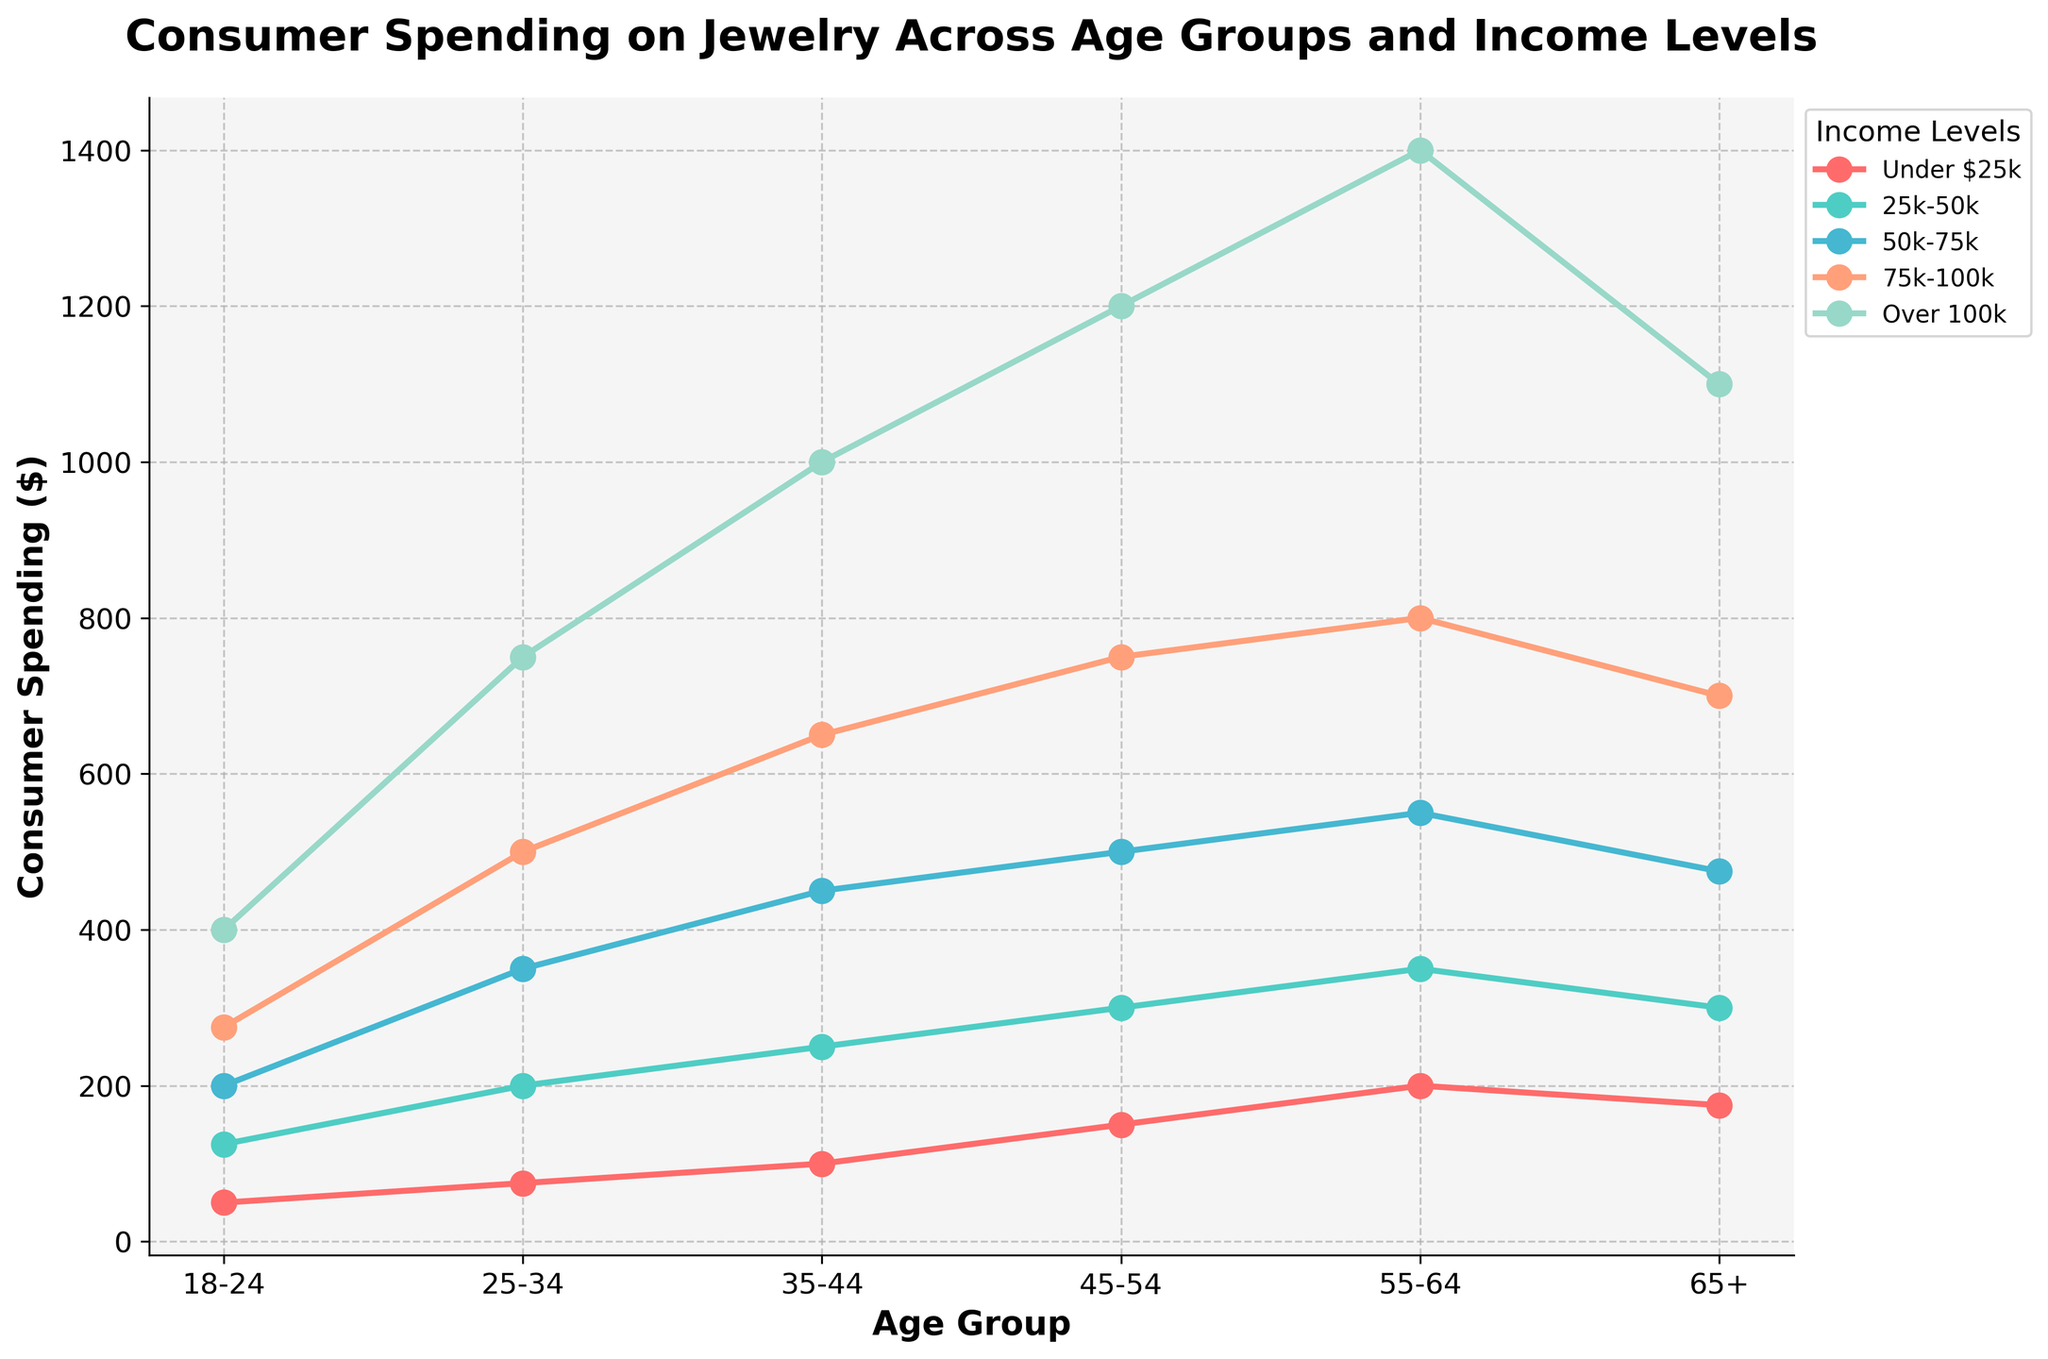What is the general trend of consumer spending on jewelry as age increases for those earning over $100k? To determine the general trend for the over $100k income level as age increases, observe the line corresponding to the "Over $100k" category. This line starts at $400 for the 18-24 age group and continuously increases to $1400 for the 55-64 age group, then slightly decreases to $1100 for the 65+ age group. The trend shows a general increase in spending with age until 64, followed by a slight decrease after 65.
Answer: Generally increasing, slight decrease after 65 Which age group shows the highest consumer spending for the income level 50k-75k? To find the highest consumer spending in the 50k-75k income level, locate the data points of the 50k-75k line for all age groups. Compare the values: 18-24 ($200), 25-34 ($350), 35-44 ($450), 45-54 ($500), 55-64 ($550), and 65+ ($475). The maximum value of $550 occurs for the 55-64 age group.
Answer: 55-64 For the 25-34 age group, how much more do consumers in the 75k-100k income level spend compared to those under $25k? Find the data points for the 25-34 age group for the 75k-100k income level ($500) and for the under $25k income level ($75). Calculate the difference between these two amounts: $500 - $75 = $425.
Answer: $425 What is the difference in consumer spending between the 35-44 and 45-54 age groups for the income level 25k-50k? Look at the data points for 35-44 ($250) and 45-54 ($300) in the 25k-50k income level. Subtract the 35-44 value from 45-54: $300 - $250 = $50.
Answer: $50 Which age group's spending shows the smallest increase when moving from the income level 25k-50k to 50k-75k? Compare the spending increase for each age group when moving from 25k-50k to 50k-75k. Calculate the differences: 18-24 ($200 - $125 = $75), 25-34 ($350 - $200 = $150), 35-44 ($450 - $250 = $200), 45-54 ($500 - $300 = $200), 55-64 ($550 - $350 = $200), 65+ ($475 - $300 = $175). The smallest increase is $75 for the 18-24 age group.
Answer: 18-24 In the 65+ age group, which two income levels have an equal difference in spending? Calculate the spending differences for each pair of consecutive income levels in the 65+ age group: Under $25k to 25k-50k ($300 - $175 = $125), 25k-50k to 50k-75k ($475 - $300 = $175), 50k-75k to 75k-100k ($700 - $475 = $225), 75k-100k to Over $100k ($1100 - $700 = $400). The pairs do not have equal differences.
Answer: None 